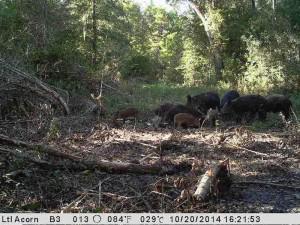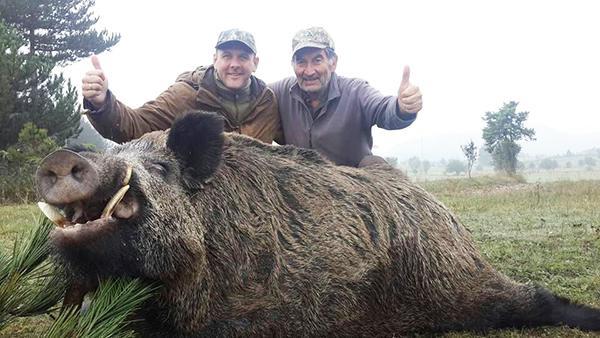The first image is the image on the left, the second image is the image on the right. Analyze the images presented: Is the assertion "One image shows at least one hunter posing behind a warthog." valid? Answer yes or no. Yes. The first image is the image on the left, the second image is the image on the right. For the images displayed, is the sentence "An image shows at least one man in a camo hat crouched behind a dead hog lying on the ground with its mouth propped open." factually correct? Answer yes or no. Yes. 